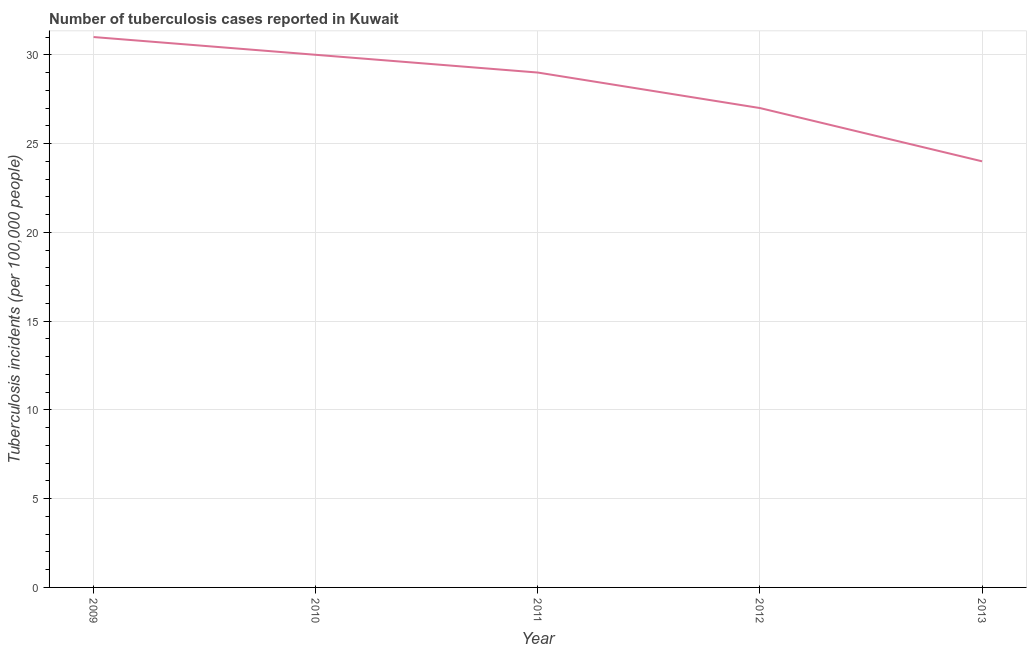What is the number of tuberculosis incidents in 2010?
Your answer should be compact. 30. Across all years, what is the maximum number of tuberculosis incidents?
Offer a terse response. 31. Across all years, what is the minimum number of tuberculosis incidents?
Provide a succinct answer. 24. What is the sum of the number of tuberculosis incidents?
Your answer should be very brief. 141. What is the difference between the number of tuberculosis incidents in 2009 and 2013?
Keep it short and to the point. 7. What is the average number of tuberculosis incidents per year?
Keep it short and to the point. 28.2. Do a majority of the years between 2009 and 2011 (inclusive) have number of tuberculosis incidents greater than 7 ?
Give a very brief answer. Yes. What is the ratio of the number of tuberculosis incidents in 2009 to that in 2013?
Keep it short and to the point. 1.29. Is the difference between the number of tuberculosis incidents in 2012 and 2013 greater than the difference between any two years?
Keep it short and to the point. No. What is the difference between the highest and the lowest number of tuberculosis incidents?
Make the answer very short. 7. Does the number of tuberculosis incidents monotonically increase over the years?
Your answer should be compact. No. How many lines are there?
Your answer should be very brief. 1. How many years are there in the graph?
Give a very brief answer. 5. What is the difference between two consecutive major ticks on the Y-axis?
Your answer should be very brief. 5. Are the values on the major ticks of Y-axis written in scientific E-notation?
Ensure brevity in your answer.  No. Does the graph contain grids?
Keep it short and to the point. Yes. What is the title of the graph?
Your response must be concise. Number of tuberculosis cases reported in Kuwait. What is the label or title of the X-axis?
Keep it short and to the point. Year. What is the label or title of the Y-axis?
Ensure brevity in your answer.  Tuberculosis incidents (per 100,0 people). What is the Tuberculosis incidents (per 100,000 people) of 2009?
Your answer should be compact. 31. What is the Tuberculosis incidents (per 100,000 people) of 2013?
Your answer should be very brief. 24. What is the difference between the Tuberculosis incidents (per 100,000 people) in 2009 and 2010?
Your response must be concise. 1. What is the difference between the Tuberculosis incidents (per 100,000 people) in 2010 and 2011?
Offer a very short reply. 1. What is the difference between the Tuberculosis incidents (per 100,000 people) in 2010 and 2013?
Offer a very short reply. 6. What is the ratio of the Tuberculosis incidents (per 100,000 people) in 2009 to that in 2010?
Offer a very short reply. 1.03. What is the ratio of the Tuberculosis incidents (per 100,000 people) in 2009 to that in 2011?
Offer a terse response. 1.07. What is the ratio of the Tuberculosis incidents (per 100,000 people) in 2009 to that in 2012?
Give a very brief answer. 1.15. What is the ratio of the Tuberculosis incidents (per 100,000 people) in 2009 to that in 2013?
Offer a terse response. 1.29. What is the ratio of the Tuberculosis incidents (per 100,000 people) in 2010 to that in 2011?
Keep it short and to the point. 1.03. What is the ratio of the Tuberculosis incidents (per 100,000 people) in 2010 to that in 2012?
Give a very brief answer. 1.11. What is the ratio of the Tuberculosis incidents (per 100,000 people) in 2010 to that in 2013?
Provide a short and direct response. 1.25. What is the ratio of the Tuberculosis incidents (per 100,000 people) in 2011 to that in 2012?
Make the answer very short. 1.07. What is the ratio of the Tuberculosis incidents (per 100,000 people) in 2011 to that in 2013?
Provide a succinct answer. 1.21. What is the ratio of the Tuberculosis incidents (per 100,000 people) in 2012 to that in 2013?
Provide a short and direct response. 1.12. 